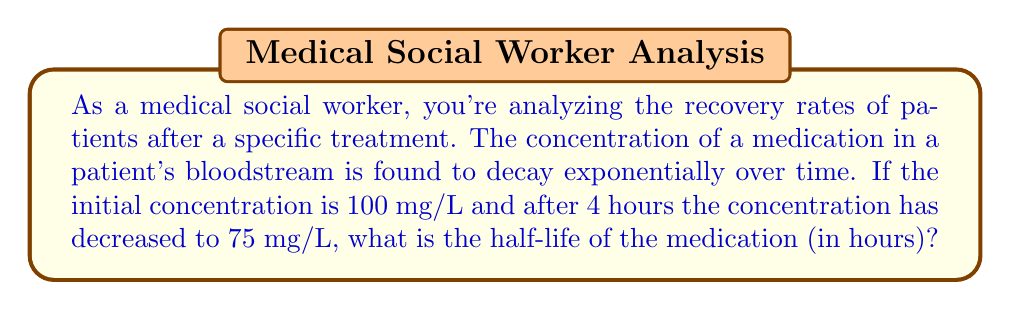Help me with this question. To solve this problem, we'll use the exponential decay model and the concept of half-life. Let's approach this step-by-step:

1) The general form of exponential decay is:

   $$C(t) = C_0 e^{-kt}$$

   Where:
   $C(t)$ is the concentration at time $t$
   $C_0$ is the initial concentration
   $k$ is the decay constant
   $t$ is time

2) We're given:
   $C_0 = 100$ mg/L
   $C(4) = 75$ mg/L
   $t = 4$ hours

3) Let's substitute these values into our equation:

   $$75 = 100 e^{-4k}$$

4) Divide both sides by 100:

   $$0.75 = e^{-4k}$$

5) Take the natural log of both sides:

   $$\ln(0.75) = -4k$$

6) Solve for $k$:

   $$k = -\frac{\ln(0.75)}{4} \approx 0.0718$$

7) Now that we have $k$, we can find the half-life. The half-life is the time it takes for the concentration to decrease to half its original value. Let's call this time $t_{1/2}$. We can write:

   $$\frac{1}{2} = e^{-kt_{1/2}}$$

8) Take the natural log of both sides:

   $$\ln(\frac{1}{2}) = -kt_{1/2}$$

9) Solve for $t_{1/2}$:

   $$t_{1/2} = -\frac{\ln(\frac{1}{2})}{k} = \frac{\ln(2)}{k}$$

10) Substitute our value for $k$:

    $$t_{1/2} = \frac{\ln(2)}{0.0718} \approx 9.66$$

Therefore, the half-life of the medication is approximately 9.66 hours.
Answer: The half-life of the medication is approximately 9.66 hours. 